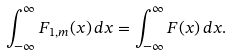Convert formula to latex. <formula><loc_0><loc_0><loc_500><loc_500>\int _ { - \infty } ^ { \infty } F _ { 1 , m } ( x ) \, d x = \int _ { - \infty } ^ { \infty } F ( x ) \, d x .</formula> 